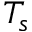<formula> <loc_0><loc_0><loc_500><loc_500>T _ { s }</formula> 